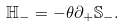Convert formula to latex. <formula><loc_0><loc_0><loc_500><loc_500>\mathbb { H } _ { - } = - \theta \partial _ { + } \mathbb { S } _ { - } .</formula> 